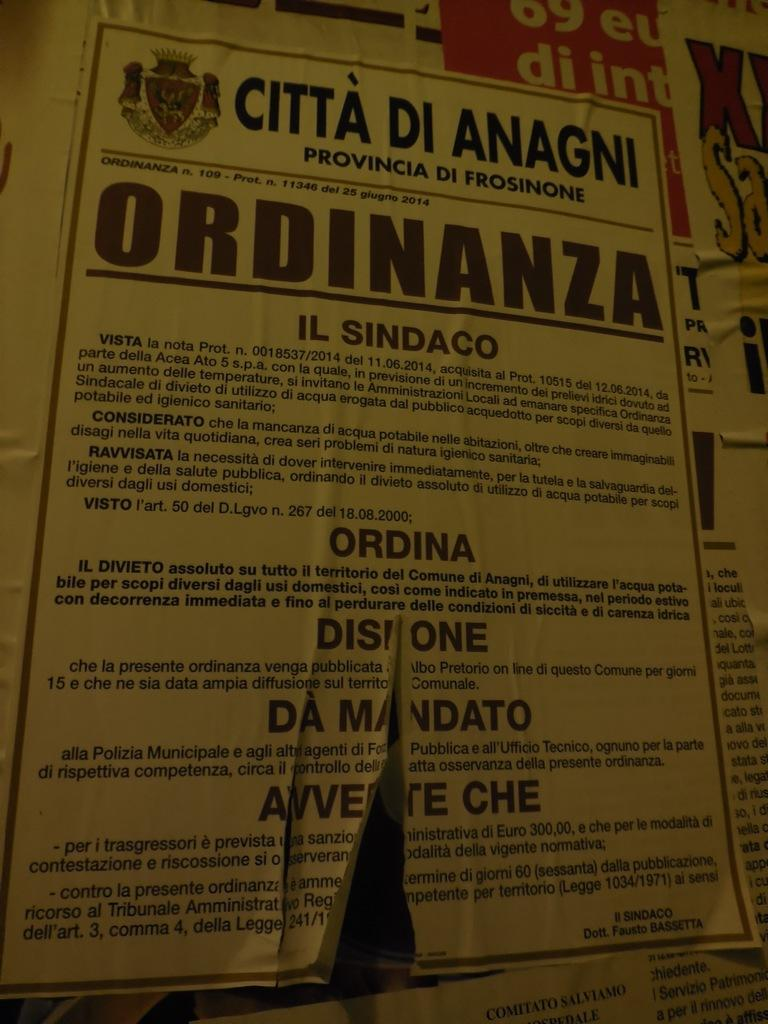<image>
Offer a succinct explanation of the picture presented. a torn paper that says 'ordinanza' on it 